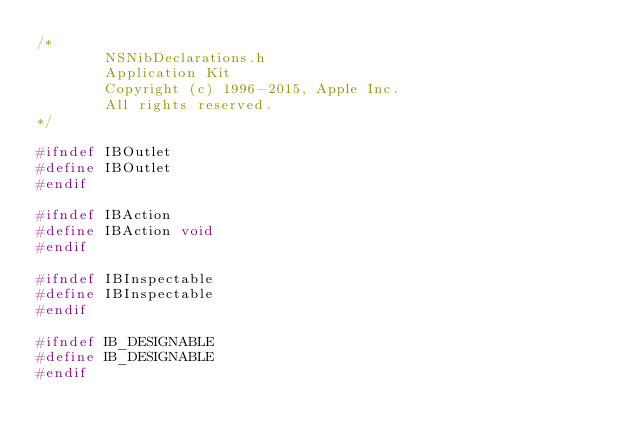<code> <loc_0><loc_0><loc_500><loc_500><_C_>/*
        NSNibDeclarations.h
        Application Kit
        Copyright (c) 1996-2015, Apple Inc.
        All rights reserved.
*/

#ifndef IBOutlet
#define IBOutlet
#endif

#ifndef IBAction
#define IBAction void
#endif

#ifndef IBInspectable
#define IBInspectable
#endif

#ifndef IB_DESIGNABLE
#define IB_DESIGNABLE
#endif

</code> 